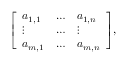<formula> <loc_0><loc_0><loc_500><loc_500>{ \left [ \begin{array} { l l l } { a _ { 1 , 1 } } & { \dots } & { a _ { 1 , n } } \\ { \vdots } & { \dots } & { \vdots } \\ { a _ { m , 1 } } & { \dots } & { a _ { m , n } } \end{array} \right ] } ,</formula> 